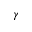<formula> <loc_0><loc_0><loc_500><loc_500>\gamma</formula> 